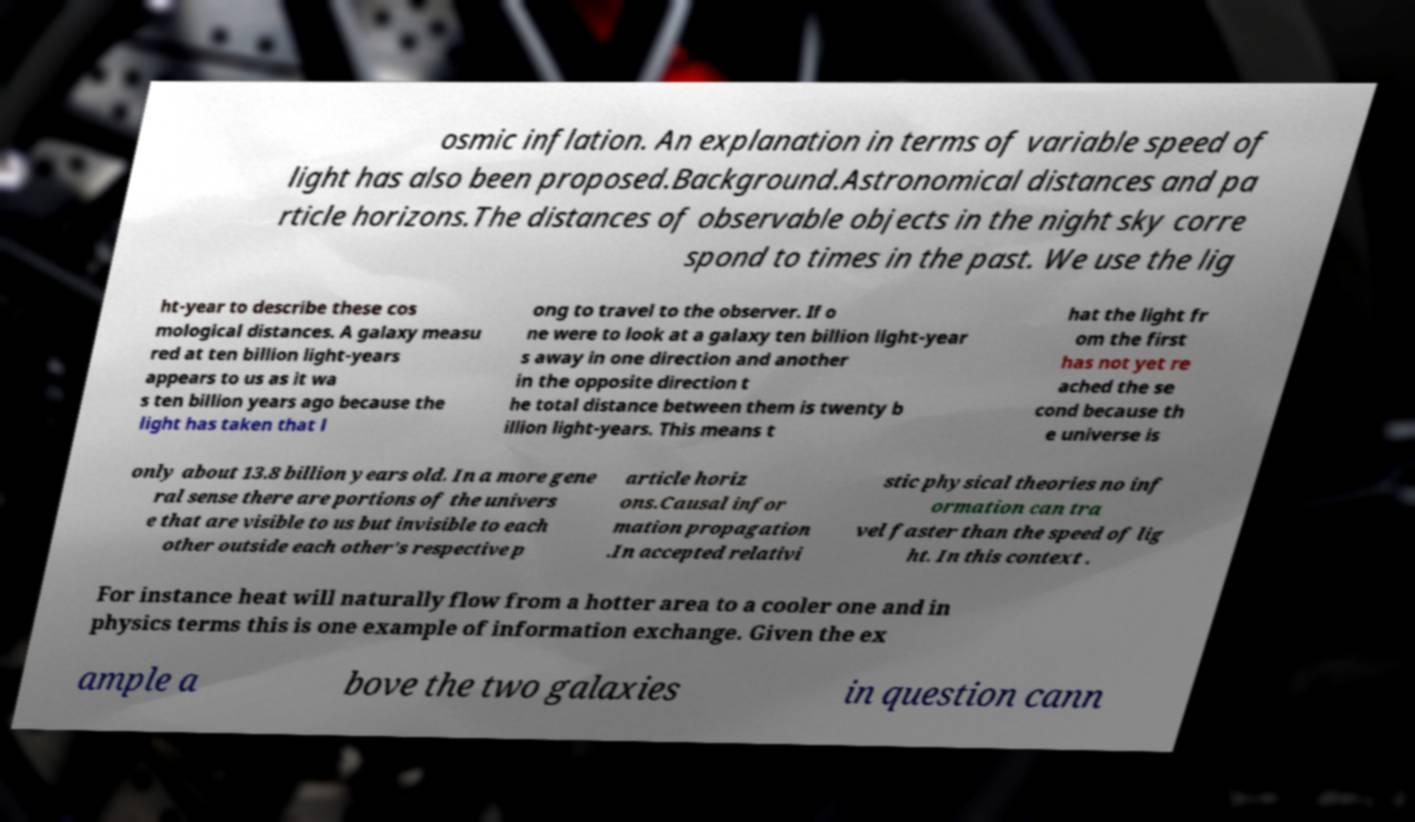Can you read and provide the text displayed in the image?This photo seems to have some interesting text. Can you extract and type it out for me? osmic inflation. An explanation in terms of variable speed of light has also been proposed.Background.Astronomical distances and pa rticle horizons.The distances of observable objects in the night sky corre spond to times in the past. We use the lig ht-year to describe these cos mological distances. A galaxy measu red at ten billion light-years appears to us as it wa s ten billion years ago because the light has taken that l ong to travel to the observer. If o ne were to look at a galaxy ten billion light-year s away in one direction and another in the opposite direction t he total distance between them is twenty b illion light-years. This means t hat the light fr om the first has not yet re ached the se cond because th e universe is only about 13.8 billion years old. In a more gene ral sense there are portions of the univers e that are visible to us but invisible to each other outside each other's respective p article horiz ons.Causal infor mation propagation .In accepted relativi stic physical theories no inf ormation can tra vel faster than the speed of lig ht. In this context . For instance heat will naturally flow from a hotter area to a cooler one and in physics terms this is one example of information exchange. Given the ex ample a bove the two galaxies in question cann 